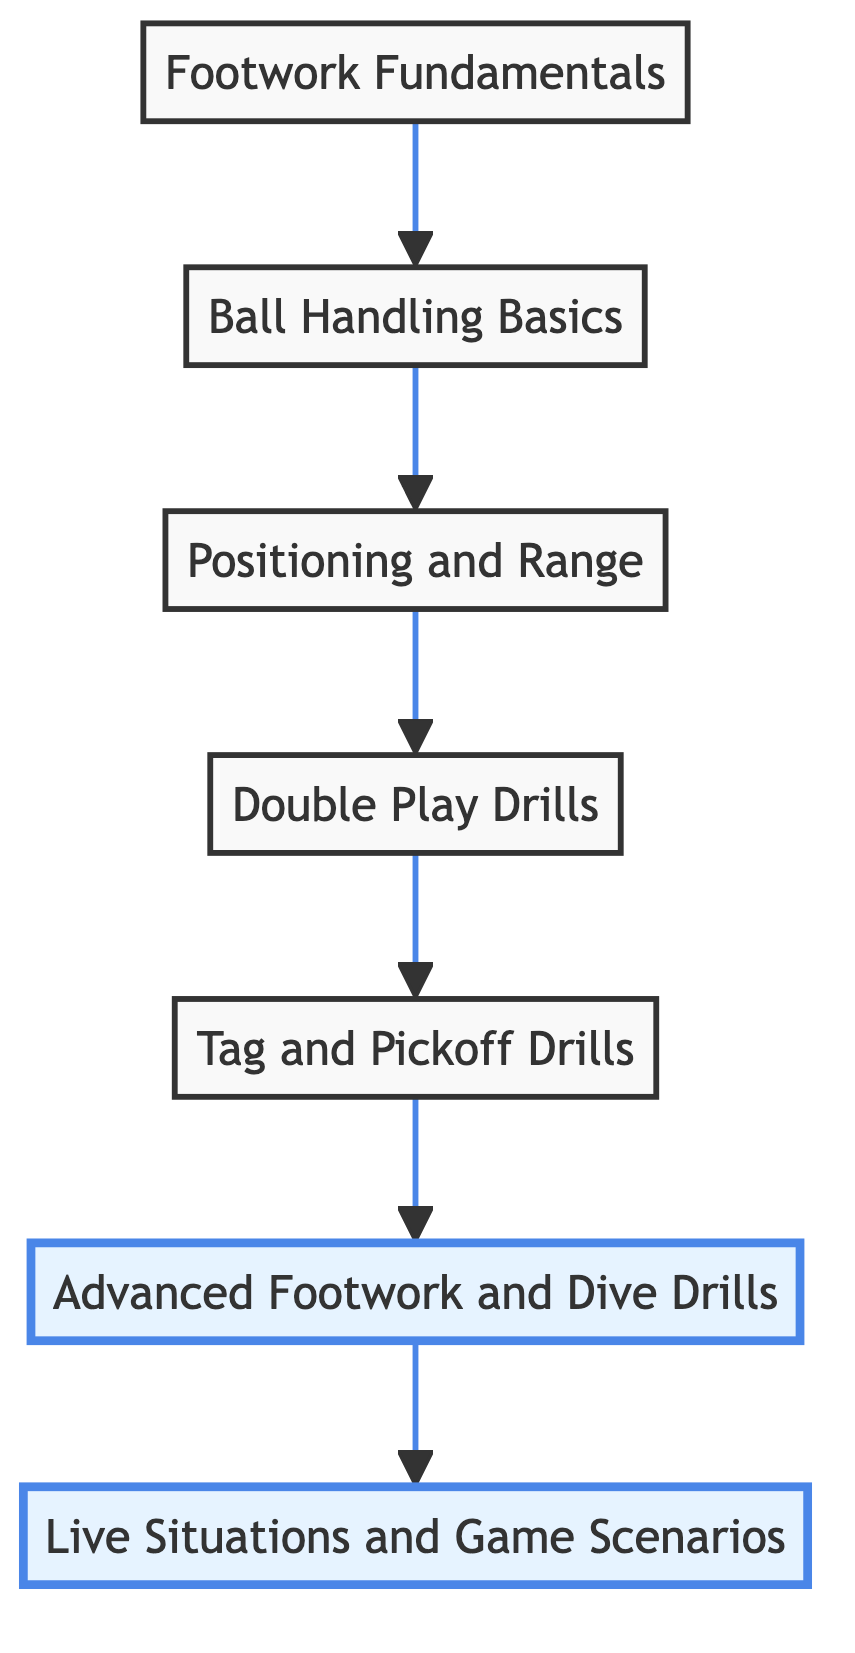What is the first step in the practice routine? The diagram starts with "Footwork Fundamentals," which is positioned at the bottom as the initial step before progressing to other drills.
Answer: Footwork Fundamentals How many total nodes are present in the diagram? By counting each unique step listed in the flow chart, we find seven nodes that represent different aspects of the practice routine.
Answer: Seven Which drill directly follows "Ball Handling Basics"? The flow shows that "Ball Handling Basics" leads to "Positioning and Range" as the next step in the practice routine.
Answer: Positioning and Range What is the last drill in the practice routine? The topmost node "Live Situations and Game Scenarios" indicates it is the final step in the progression of drills to apply the learned skills.
Answer: Live Situations and Game Scenarios What two drills are highlighted in the diagram? The classes applied indicate that "Live Situations and Game Scenarios" and "Advanced Footwork and Dive Drills" are both visually emphasized, showing their significance in the routine.
Answer: Live Situations and Game Scenarios, Advanced Footwork and Dive Drills What is the relationship between "Double Play Drills" and "Tag and Pickoff Drills"? The flow connects "Double Play Drills" directly leading into "Tag and Pickoff Drills," indicating that tag and pickoff practice is based on or follows the double play technique practice.
Answer: Double Play Drills lead to Tag and Pickoff Drills Which drill comes before the "Advanced Footwork and Dive Drills"? In the flow chart, "Tag and Pickoff Drills" is the immediate predecessor to the "Advanced Footwork and Dive Drills," showing the sequence of skill progression.
Answer: Tag and Pickoff Drills 